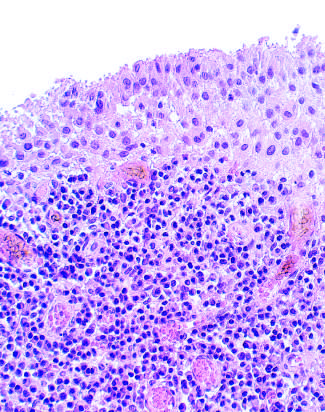did confluent necrosis contain a dense lymphoid aggregate?
Answer the question using a single word or phrase. No 